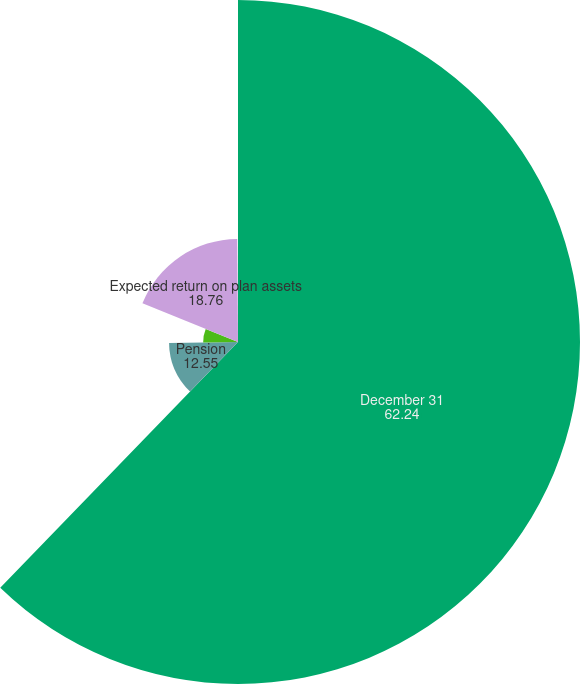Convert chart. <chart><loc_0><loc_0><loc_500><loc_500><pie_chart><fcel>December 31<fcel>Pension<fcel>Other postretirement benefits<fcel>Expected return on plan assets<fcel>Rate of compensation increase<nl><fcel>62.24%<fcel>12.55%<fcel>6.34%<fcel>18.76%<fcel>0.12%<nl></chart> 